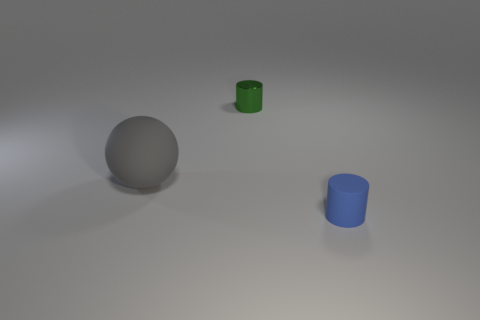Add 3 gray things. How many objects exist? 6 Subtract all cylinders. How many objects are left? 1 Add 3 big gray matte spheres. How many big gray matte spheres exist? 4 Subtract 0 brown cylinders. How many objects are left? 3 Subtract all tiny blue cubes. Subtract all small green metal cylinders. How many objects are left? 2 Add 2 big gray objects. How many big gray objects are left? 3 